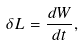Convert formula to latex. <formula><loc_0><loc_0><loc_500><loc_500>\delta L = \frac { d W } { d t } ,</formula> 